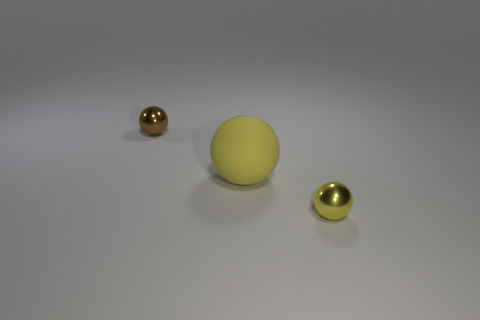Add 2 spheres. How many objects exist? 5 Subtract all large yellow matte objects. Subtract all metal balls. How many objects are left? 0 Add 3 large rubber things. How many large rubber things are left? 4 Add 2 large yellow spheres. How many large yellow spheres exist? 3 Subtract 0 purple spheres. How many objects are left? 3 